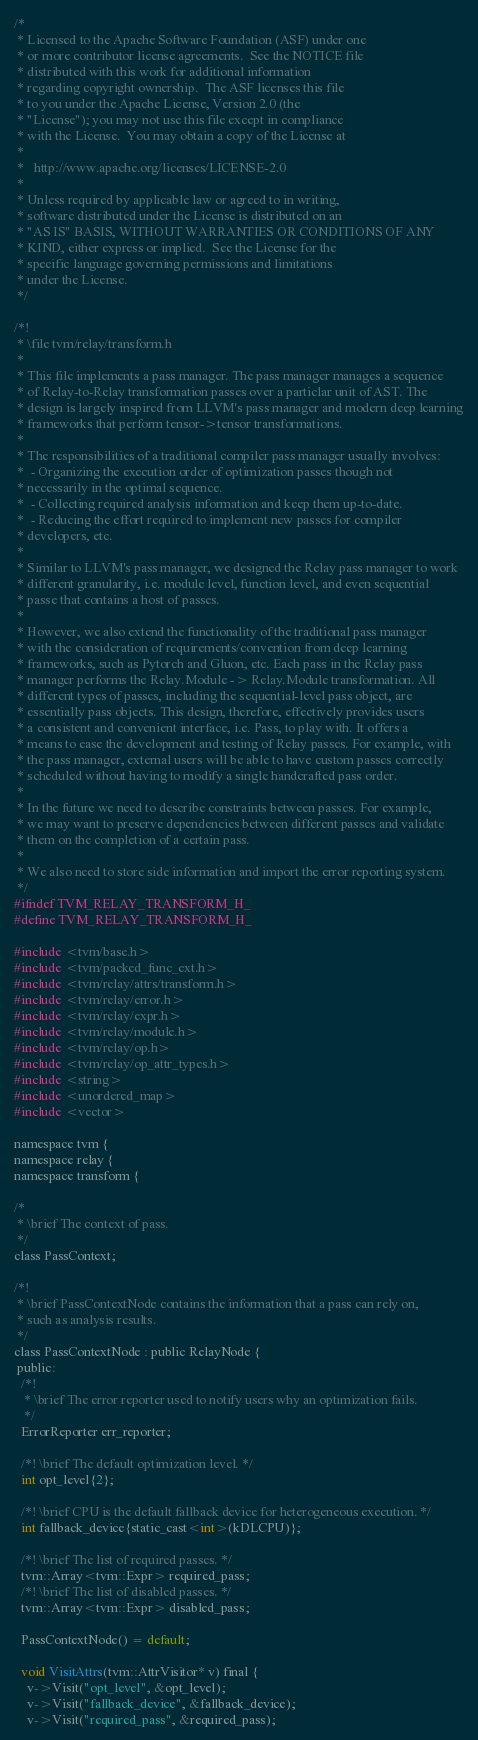Convert code to text. <code><loc_0><loc_0><loc_500><loc_500><_C_>/*
 * Licensed to the Apache Software Foundation (ASF) under one
 * or more contributor license agreements.  See the NOTICE file
 * distributed with this work for additional information
 * regarding copyright ownership.  The ASF licenses this file
 * to you under the Apache License, Version 2.0 (the
 * "License"); you may not use this file except in compliance
 * with the License.  You may obtain a copy of the License at
 *
 *   http://www.apache.org/licenses/LICENSE-2.0
 *
 * Unless required by applicable law or agreed to in writing,
 * software distributed under the License is distributed on an
 * "AS IS" BASIS, WITHOUT WARRANTIES OR CONDITIONS OF ANY
 * KIND, either express or implied.  See the License for the
 * specific language governing permissions and limitations
 * under the License.
 */

/*!
 * \file tvm/relay/transform.h
 *
 * This file implements a pass manager. The pass manager manages a sequence
 * of Relay-to-Relay transformation passes over a particlar unit of AST. The
 * design is largely inspired from LLVM's pass manager and modern deep learning
 * frameworks that perform tensor->tensor transformations.
 *
 * The responsibilities of a traditional compiler pass manager usually involves:
 *  - Organizing the execution order of optimization passes though not
 * necessarily in the optimal sequence.
 *  - Collecting required analysis information and keep them up-to-date.
 *  - Reducing the effort required to implement new passes for compiler
 * developers, etc.
 *
 * Similar to LLVM's pass manager, we designed the Relay pass manager to work
 * different granularity, i.e. module level, function level, and even sequential
 * passe that contains a host of passes.
 *
 * However, we also extend the functionality of the traditional pass manager
 * with the consideration of requirements/convention from deep learning
 * frameworks, such as Pytorch and Gluon, etc. Each pass in the Relay pass
 * manager performs the Relay.Module -> Relay.Module transformation. All
 * different types of passes, including the sequential-level pass object, are
 * essentially pass objects. This design, therefore, effectively provides users
 * a consistent and convenient interface, i.e. Pass, to play with. It offers a
 * means to ease the development and testing of Relay passes. For example, with
 * the pass manager, external users will be able to have custom passes correctly
 * scheduled without having to modify a single handcrafted pass order.
 *
 * In the future we need to describe constraints between passes. For example,
 * we may want to preserve dependencies between different passes and validate
 * them on the completion of a certain pass.
 *
 * We also need to store side information and import the error reporting system.
 */
#ifndef TVM_RELAY_TRANSFORM_H_
#define TVM_RELAY_TRANSFORM_H_

#include <tvm/base.h>
#include <tvm/packed_func_ext.h>
#include <tvm/relay/attrs/transform.h>
#include <tvm/relay/error.h>
#include <tvm/relay/expr.h>
#include <tvm/relay/module.h>
#include <tvm/relay/op.h>
#include <tvm/relay/op_attr_types.h>
#include <string>
#include <unordered_map>
#include <vector>

namespace tvm {
namespace relay {
namespace transform {

/*
 * \brief The context of pass.
 */
class PassContext;

/*!
 * \brief PassContextNode contains the information that a pass can rely on,
 * such as analysis results.
 */
class PassContextNode : public RelayNode {
 public:
  /*!
   * \brief The error reporter used to notify users why an optimization fails.
   */
  ErrorReporter err_reporter;

  /*! \brief The default optimization level. */
  int opt_level{2};

  /*! \brief CPU is the default fallback device for heterogeneous execution. */
  int fallback_device{static_cast<int>(kDLCPU)};

  /*! \brief The list of required passes. */
  tvm::Array<tvm::Expr> required_pass;
  /*! \brief The list of disabled passes. */
  tvm::Array<tvm::Expr> disabled_pass;

  PassContextNode() = default;

  void VisitAttrs(tvm::AttrVisitor* v) final {
    v->Visit("opt_level", &opt_level);
    v->Visit("fallback_device", &fallback_device);
    v->Visit("required_pass", &required_pass);</code> 